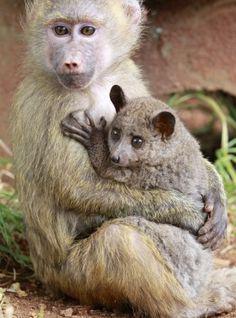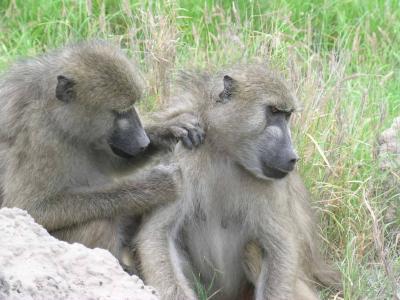The first image is the image on the left, the second image is the image on the right. Given the left and right images, does the statement "In one of the images there is a baby monkey cuddled in the arms of an adult monkey." hold true? Answer yes or no. Yes. The first image is the image on the left, the second image is the image on the right. For the images shown, is this caption "A baboon is hugging an animal to its chest in one image." true? Answer yes or no. Yes. 